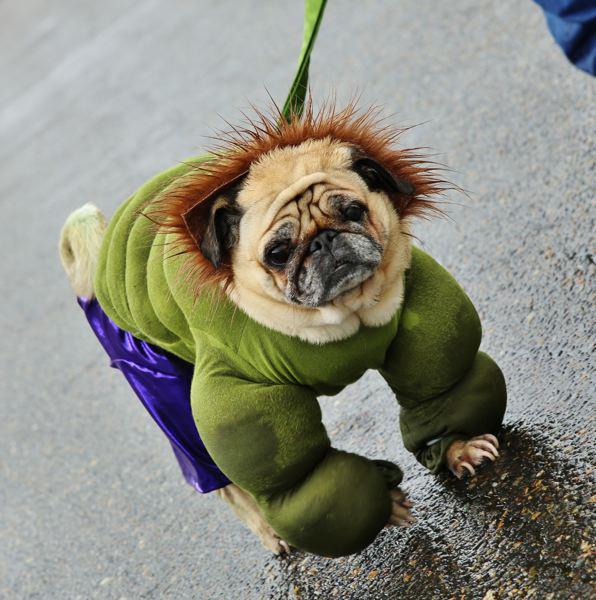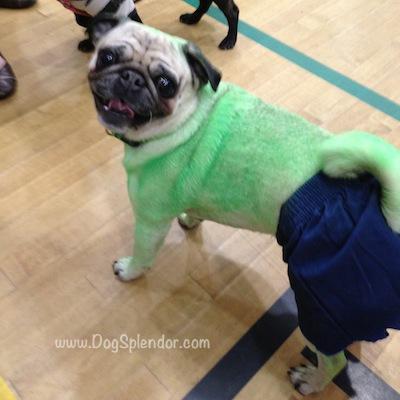The first image is the image on the left, the second image is the image on the right. For the images shown, is this caption "A dog is showing its tongue in the right image." true? Answer yes or no. Yes. The first image is the image on the left, the second image is the image on the right. Assess this claim about the two images: "One image shows a pug with green-dyed fur wearing blue shorts and gazing toward the camera.". Correct or not? Answer yes or no. Yes. 